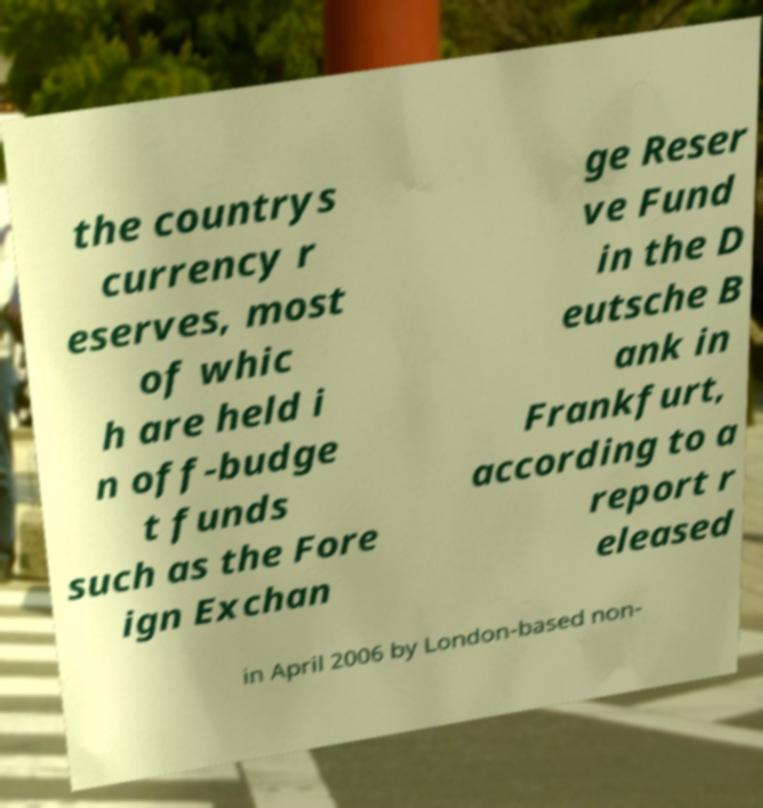Please identify and transcribe the text found in this image. the countrys currency r eserves, most of whic h are held i n off-budge t funds such as the Fore ign Exchan ge Reser ve Fund in the D eutsche B ank in Frankfurt, according to a report r eleased in April 2006 by London-based non- 